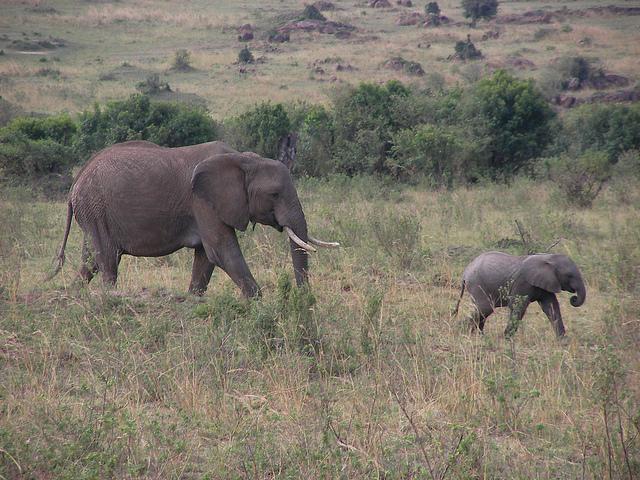How many baby elephants are in the photo?
Write a very short answer. 1. Are there 3 elephants?
Keep it brief. No. Is the grass tall?
Answer briefly. Yes. Are the elephants close together?
Keep it brief. Yes. What color is the ground?
Write a very short answer. Green. Is this a forest?
Keep it brief. No. Where are these elephants going?
Give a very brief answer. Walking. Which animal has a longer tail?
Keep it brief. Big one. How many elephants are there?
Short answer required. 2. What age is the baby elephant?
Concise answer only. 1 year old. Are the animals drinking?
Short answer required. No. 